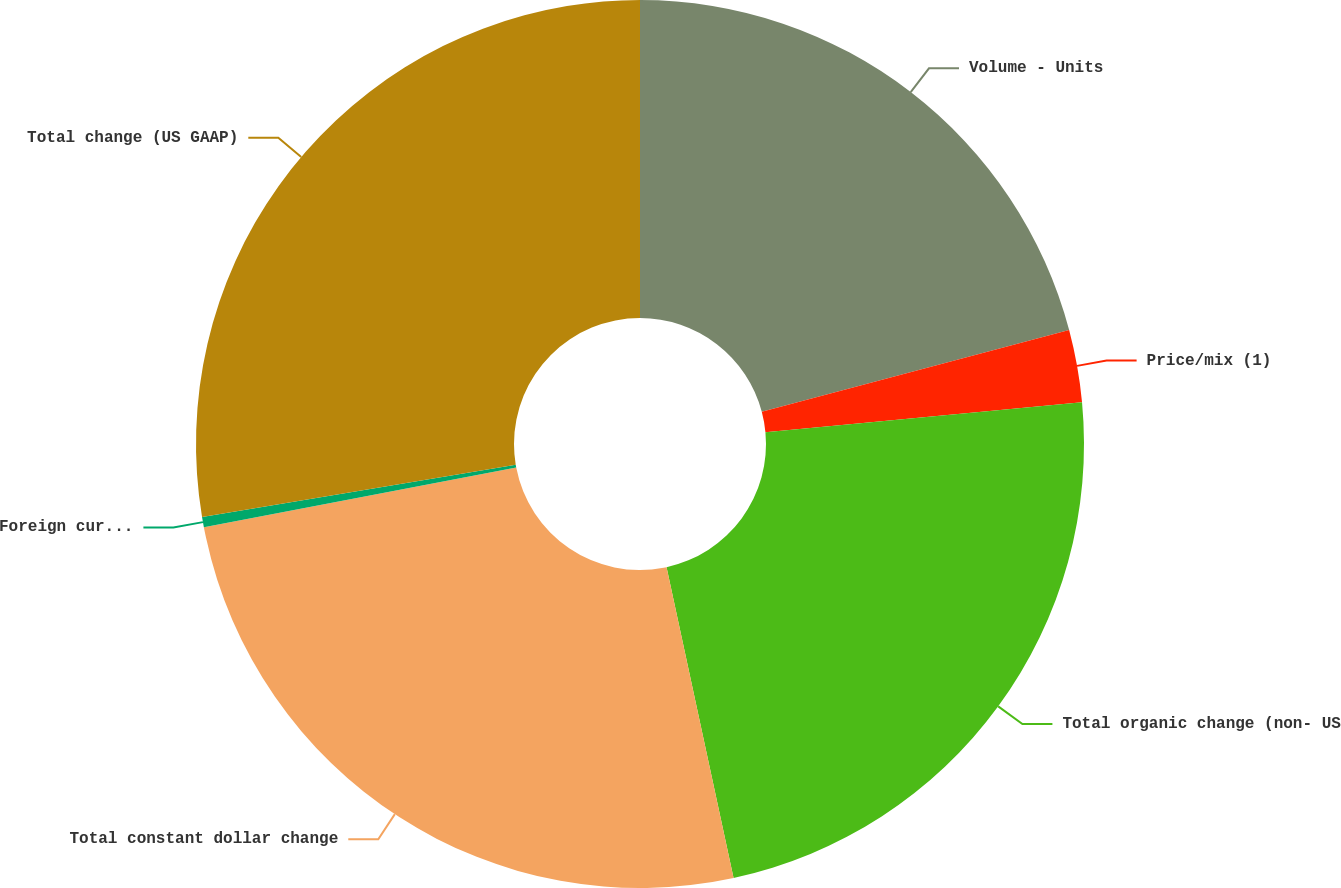<chart> <loc_0><loc_0><loc_500><loc_500><pie_chart><fcel>Volume - Units<fcel>Price/mix (1)<fcel>Total organic change (non- US<fcel>Total constant dollar change<fcel>Foreign currency translation<fcel>Total change (US GAAP)<nl><fcel>20.87%<fcel>2.63%<fcel>23.12%<fcel>25.38%<fcel>0.37%<fcel>27.63%<nl></chart> 